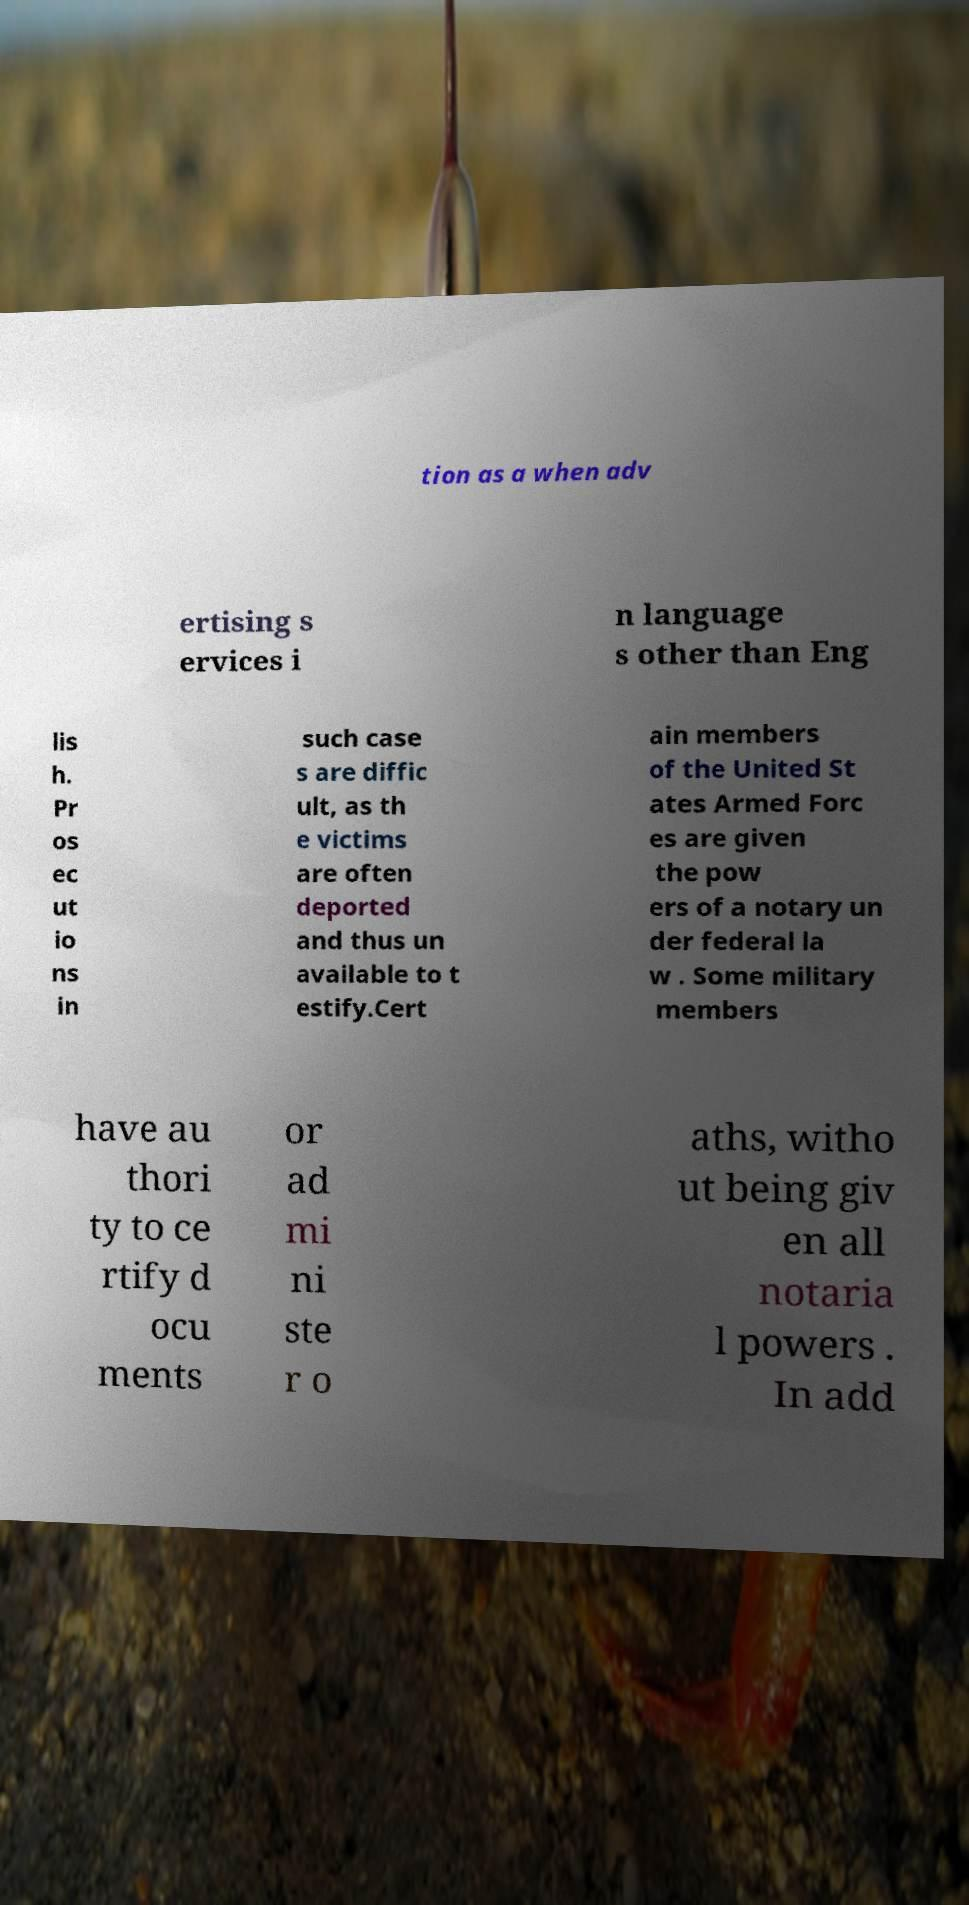Could you assist in decoding the text presented in this image and type it out clearly? tion as a when adv ertising s ervices i n language s other than Eng lis h. Pr os ec ut io ns in such case s are diffic ult, as th e victims are often deported and thus un available to t estify.Cert ain members of the United St ates Armed Forc es are given the pow ers of a notary un der federal la w . Some military members have au thori ty to ce rtify d ocu ments or ad mi ni ste r o aths, witho ut being giv en all notaria l powers . In add 